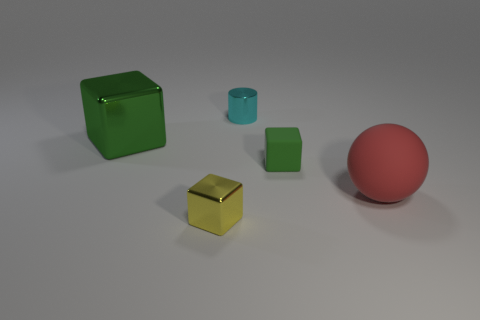What number of objects are big objects or small blocks that are in front of the big red ball?
Offer a very short reply. 3. What is the material of the red thing?
Offer a very short reply. Rubber. Is the material of the red object the same as the big green thing?
Make the answer very short. No. What number of metal objects are either red objects or tiny purple objects?
Ensure brevity in your answer.  0. What is the shape of the object left of the yellow metallic thing?
Offer a very short reply. Cube. There is a red ball that is the same material as the small green block; what is its size?
Provide a succinct answer. Large. There is a thing that is both in front of the small green cube and right of the small yellow block; what shape is it?
Give a very brief answer. Sphere. Is the color of the small block to the right of the tiny cyan object the same as the large cube?
Your response must be concise. Yes. Does the small metallic thing behind the red rubber sphere have the same shape as the green thing that is to the right of the green metal cube?
Offer a very short reply. No. What is the size of the green cube in front of the green metal object?
Make the answer very short. Small. 